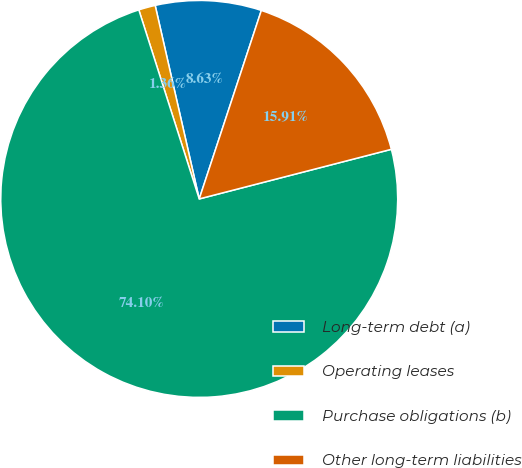<chart> <loc_0><loc_0><loc_500><loc_500><pie_chart><fcel>Long-term debt (a)<fcel>Operating leases<fcel>Purchase obligations (b)<fcel>Other long-term liabilities<nl><fcel>8.63%<fcel>1.36%<fcel>74.1%<fcel>15.91%<nl></chart> 